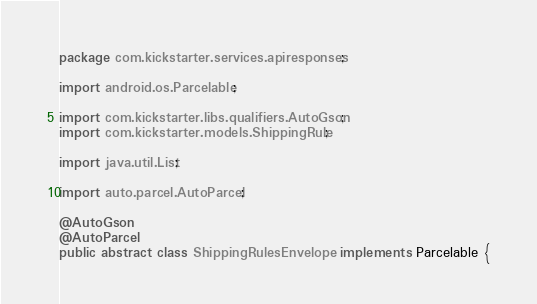Convert code to text. <code><loc_0><loc_0><loc_500><loc_500><_Java_>package com.kickstarter.services.apiresponses;

import android.os.Parcelable;

import com.kickstarter.libs.qualifiers.AutoGson;
import com.kickstarter.models.ShippingRule;

import java.util.List;

import auto.parcel.AutoParcel;

@AutoGson
@AutoParcel
public abstract class ShippingRulesEnvelope implements Parcelable {</code> 